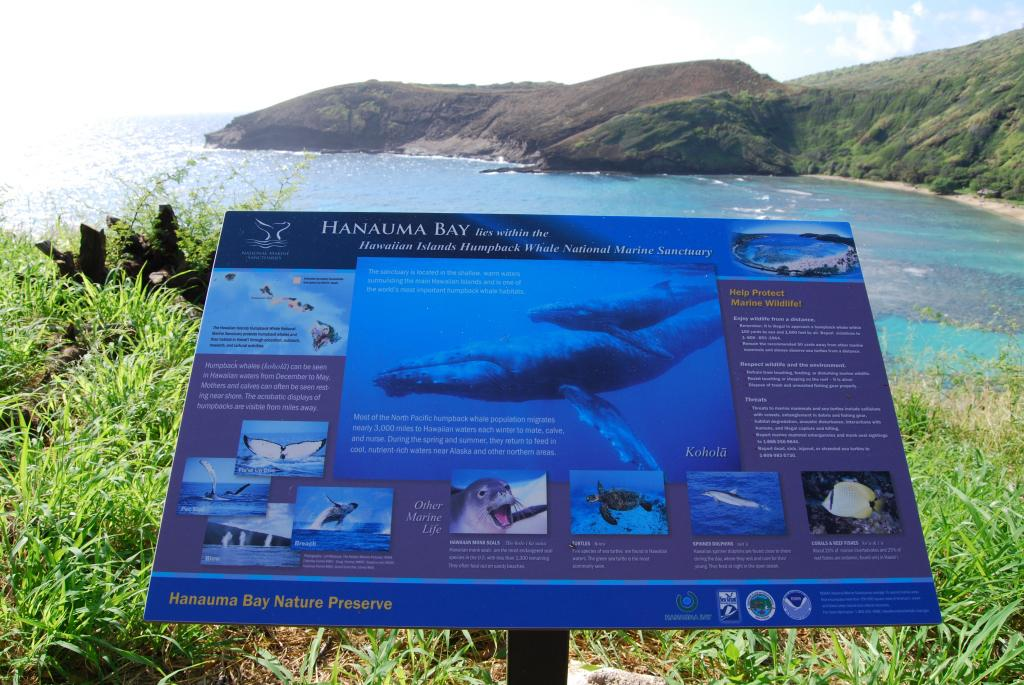What is the color of the board in the image? The board in the image is blue. What is depicted on the board? There are animal pictures on the board. What type of natural environment can be seen in the background of the image? There is grass, water, a mountain, and the sky visible in the background of the image. What type of holiday is being celebrated in the image? There is no indication of a holiday being celebrated in the image. How many ranges of mountains are visible in the image? There is only one mountain visible in the image, not a range of mountains. 